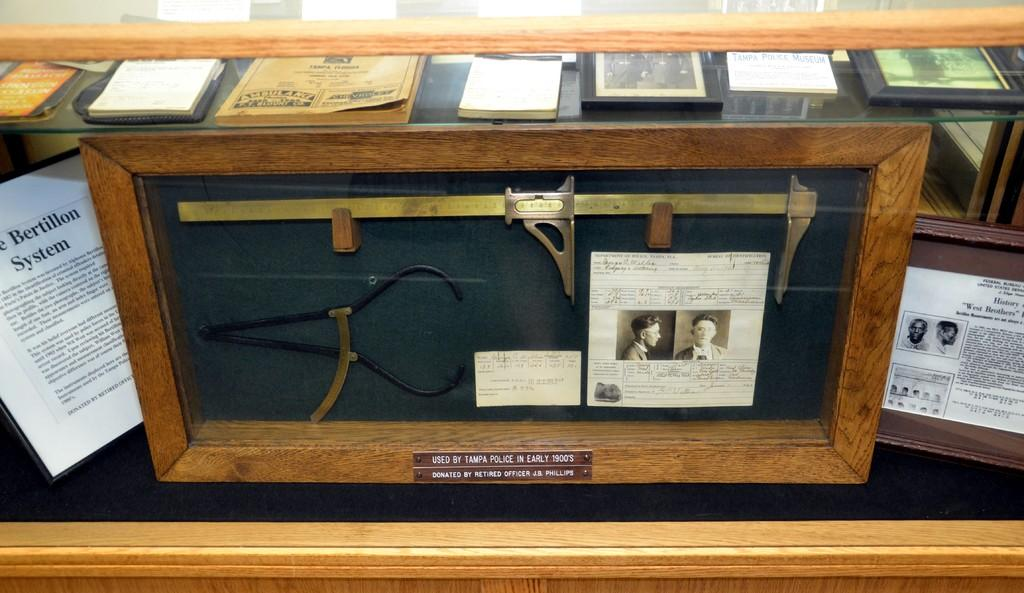What type of measuring instrument is visible in the image? There is a Vernier caliper scale in the image. What else can be seen in the image besides the measuring instrument? There are various books placed in the image. Is there a bag of groceries visible in the image? No, there is no bag of groceries present in the image. Can you compare the size of the books to the Vernier caliper scale in the image? It is not possible to make a comparison between the size of the books and the Vernier caliper scale in the image, as the provided facts do not give any information about the size of the books. 